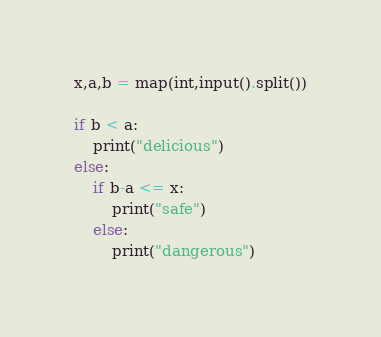<code> <loc_0><loc_0><loc_500><loc_500><_Python_>x,a,b = map(int,input().split())

if b < a:
    print("delicious")
else:
    if b-a <= x:
        print("safe")
    else:
        print("dangerous")</code> 